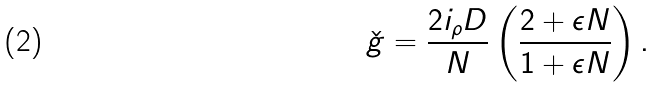<formula> <loc_0><loc_0><loc_500><loc_500>\check { g } = \frac { 2 i _ { \rho } D } { N } \left ( \frac { 2 + \epsilon N } { 1 + \epsilon N } \right ) .</formula> 